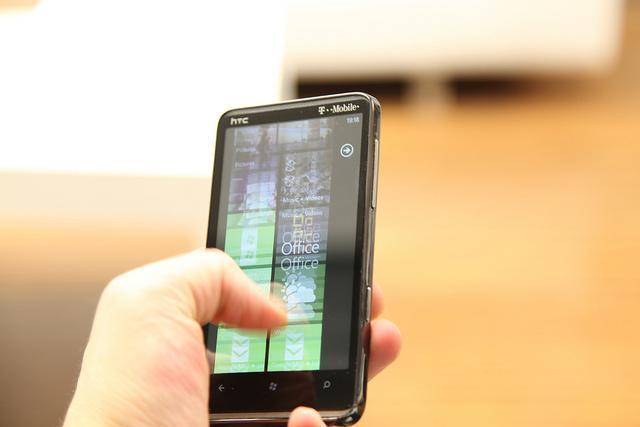How many cell phones are there?
Give a very brief answer. 1. How many people can you see?
Give a very brief answer. 1. 